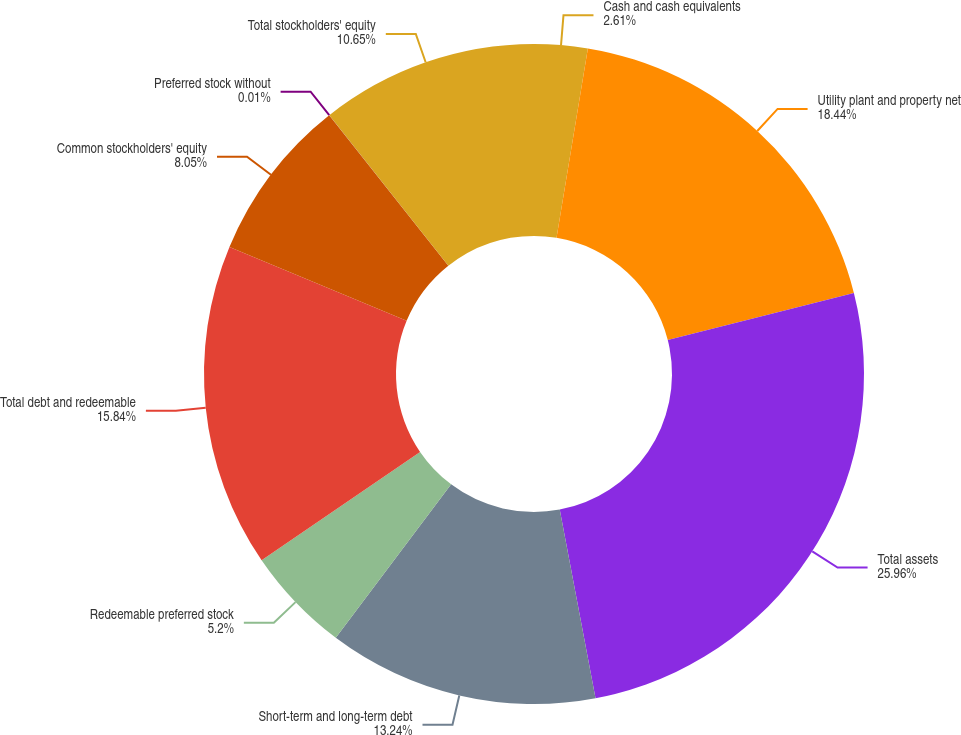<chart> <loc_0><loc_0><loc_500><loc_500><pie_chart><fcel>Cash and cash equivalents<fcel>Utility plant and property net<fcel>Total assets<fcel>Short-term and long-term debt<fcel>Redeemable preferred stock<fcel>Total debt and redeemable<fcel>Common stockholders' equity<fcel>Preferred stock without<fcel>Total stockholders' equity<nl><fcel>2.61%<fcel>18.44%<fcel>25.97%<fcel>13.24%<fcel>5.2%<fcel>15.84%<fcel>8.05%<fcel>0.01%<fcel>10.65%<nl></chart> 